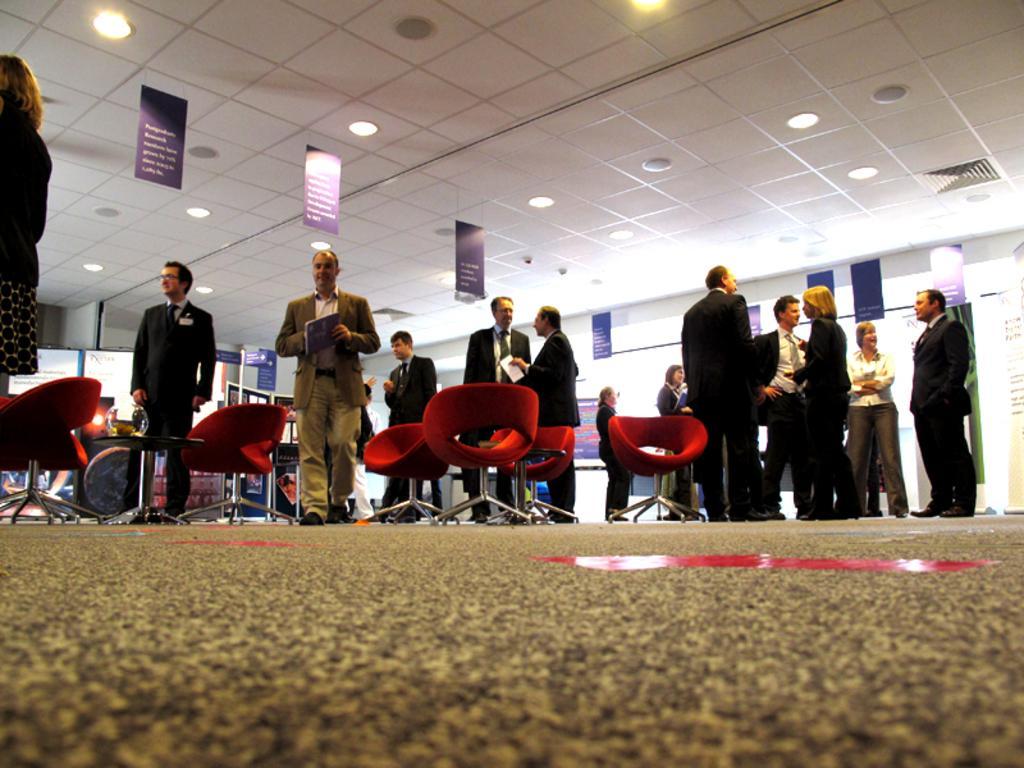Could you give a brief overview of what you see in this image? In this image we can see persons standing on the floor and holding papers in their hands. At the top of the image we can see electric lights and advertisements to the roof. At the bottom of the image we can see chairs and floor. 